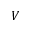Convert formula to latex. <formula><loc_0><loc_0><loc_500><loc_500>V</formula> 